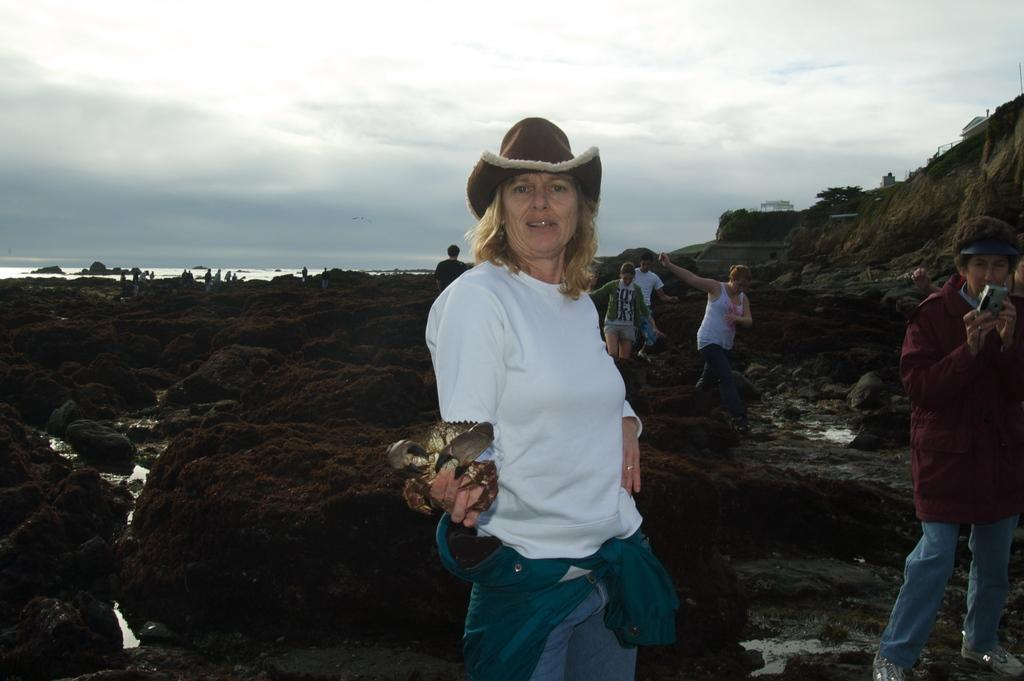What is happening in the image involving the group of people? Some people are standing, while others are walking on rocks. What objects can be seen in the image related to the group of people? A camera is visible in the image. What natural elements are present in the image? There is water and the sky with clouds visible in the background. What type of agreement is being signed by the people in the image? There is no indication in the image that the people are signing any agreement. --- 